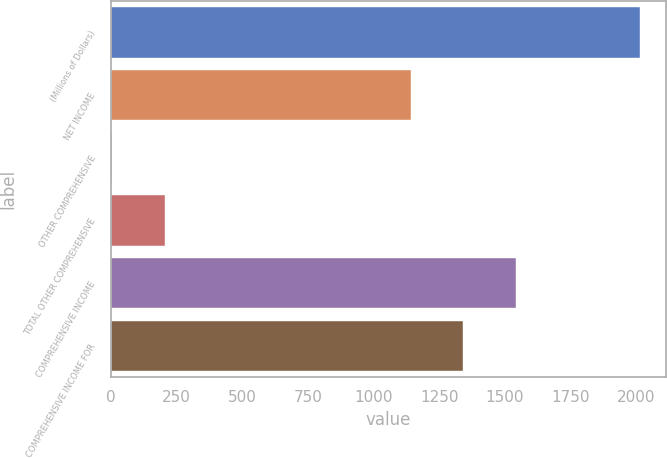<chart> <loc_0><loc_0><loc_500><loc_500><bar_chart><fcel>(Millions of Dollars)<fcel>NET INCOME<fcel>OTHER COMPREHENSIVE<fcel>TOTAL OTHER COMPREHENSIVE<fcel>COMPREHENSIVE INCOME<fcel>COMPREHENSIVE INCOME FOR<nl><fcel>2012<fcel>1141<fcel>5<fcel>205.7<fcel>1542.4<fcel>1341.7<nl></chart> 